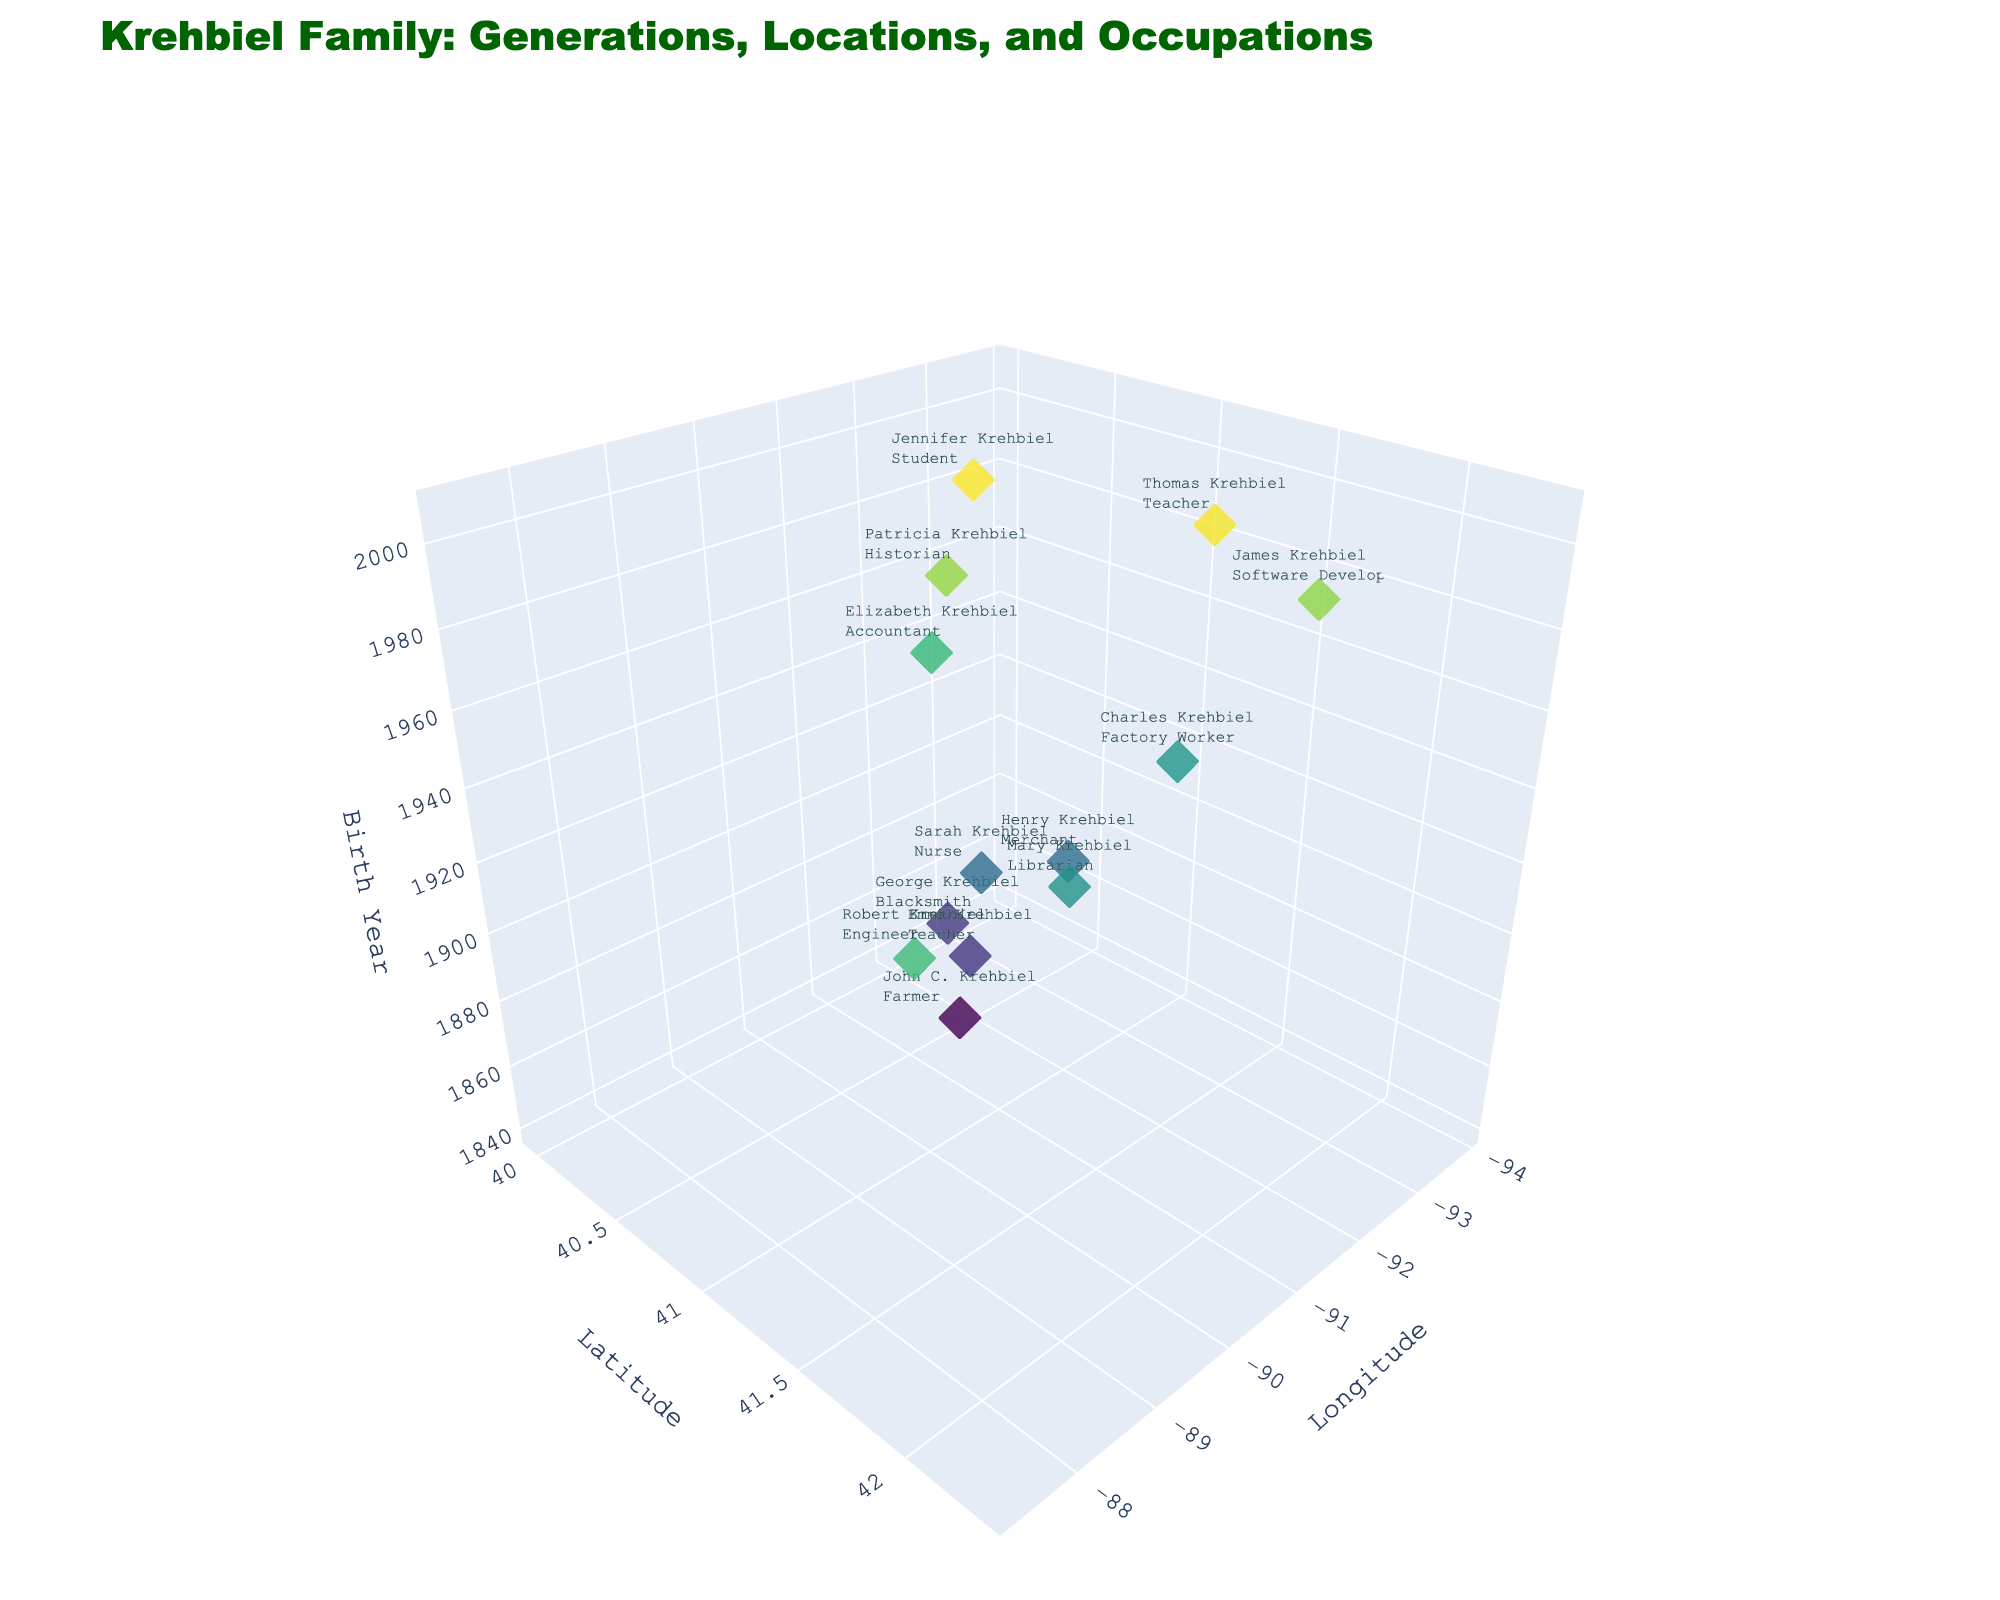What does the title of the plot read? The plot title is usually displayed at the top of the figure and provides a summary of what the plot represents. In this case, it reads "Krehbiel Family: Generations, Locations, and Occupations"
Answer: Krehbiel Family: Generations, Locations, and Occupations What are the axes labels of the plot? The axes labels describe what each axis represents. The labels can be found at the ends of the axes. Here, they are 'Longitude', 'Latitude', and 'Birth Year'
Answer: Longitude, Latitude, Birth Year How many data points are in the plot? Each data point represents a descendant of the Krehbiel family. By counting the markers on the plot, we find there are 13 data points. This matches the number of entries in the provided data.
Answer: 13 Who is the oldest person in the Krehbiel family according to the plot? Looking at the 'Birth Year' axis, the oldest person would have the earliest birth year, which is located at the lowest z-value. John C. Krehbiel was born in 1845.
Answer: John C. Krehbiel How many different occupations are represented in the plot? By observing the text associated with the markers, we see that there are a variety of occupations. Counting the unique occupations mentioned, we get Farmer, Teacher (appears twice), Blacksmith, Nurse, Merchant, Librarian, Factory Worker, Accountant, Engineer, Software Developer, Historian, and Student. There are 11 distinct occupations.
Answer: 11 Which person has the most recent birth year and what is their occupation? The most recent birth year is the highest value on the 'Birth Year' axis. Jennifer Krehbiel, born in 2002, is the person with the most recent birth year, and her occupation is Student.
Answer: Jennifer Krehbiel, Student What is the birth year range of the Krehbiel family descendants shown in the plot? To find the birth year range, subtract the earliest birth year from the most recent one. The earliest is 1845 and the most recent is 2002. So, the range is 2002 - 1845 = 157 years.
Answer: 157 years Who has the occupation of Historian and in what year were they born? The occupation text for each marker can be scanned to find the Historian. Patricia Krehbiel has this occupation, and she was born in 1977.
Answer: Patricia Krehbiel, 1977 Which family member's marker is located the furthest north? The furthest north marker corresponds to the highest value on the 'Latitude' axis. By observing the markers, Mary Krehbiel, at latitude 41.5, is the furthest north.
Answer: Mary Krehbiel What is the average birth year of the family members born in the 20th century? First, identify all family members born in the 20th century (1901-2000): Sarah (1900), Henry (1902), Mary (1925), Charles (1927), Elizabeth (1950), Robert (1952), James (1975), and Patricia (1977). Their birth years are 1900, 1902, 1925, 1927, 1950, 1952, 1975, and 1977. Adding these, we get 15308. Dividing by 8 (number of people), the average is 15308 / 8 = 1913.5.
Answer: 1913.5 